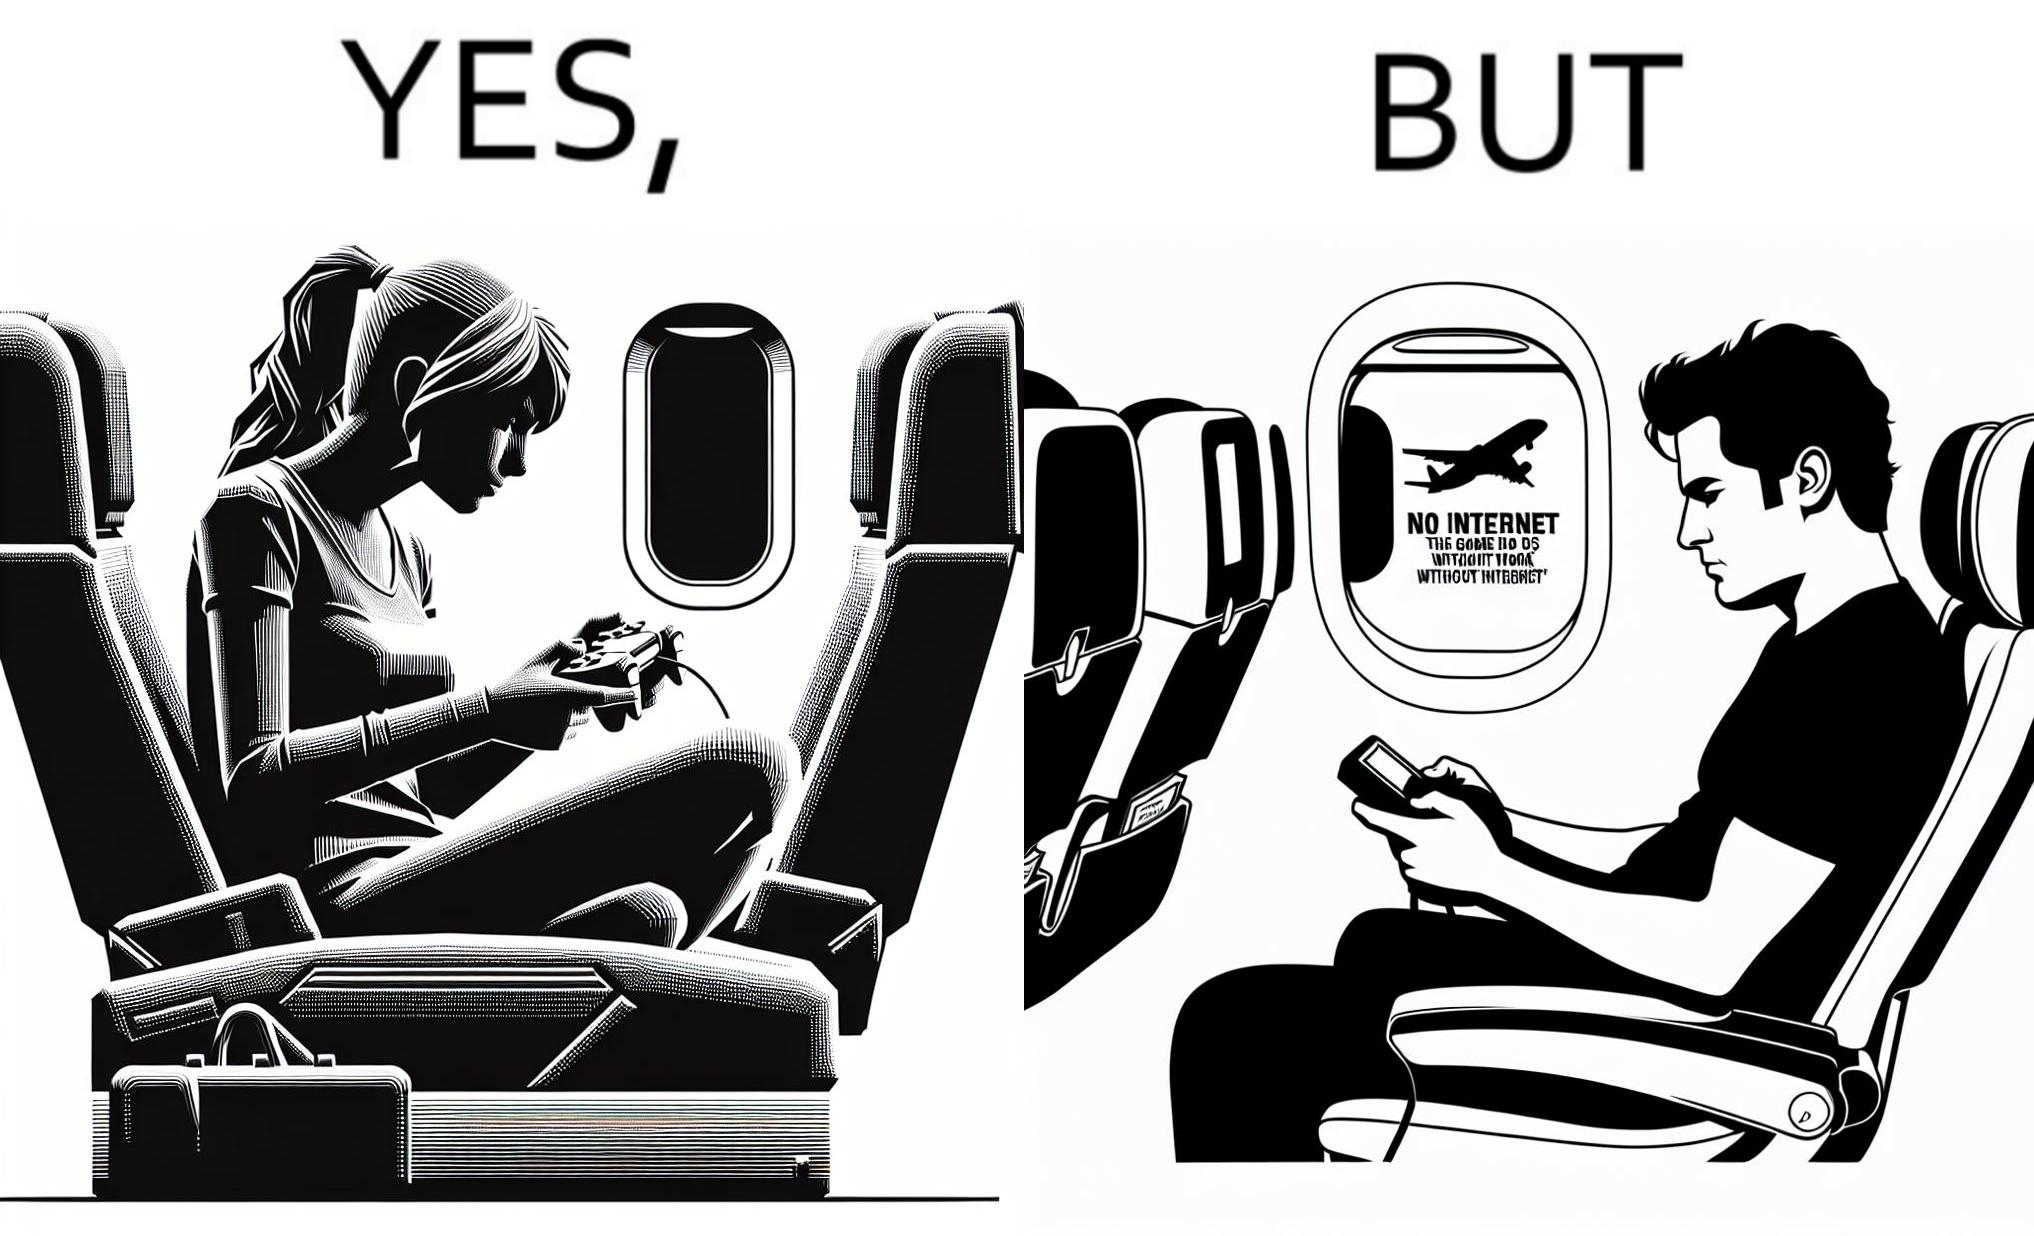What does this image depict? The image is ironic, as the person is holding the game console to play a game during the flight. However, the person is unable to play the game, as the game requires internet (as is the case with many modern games), and internet is unavailable in many lights. 